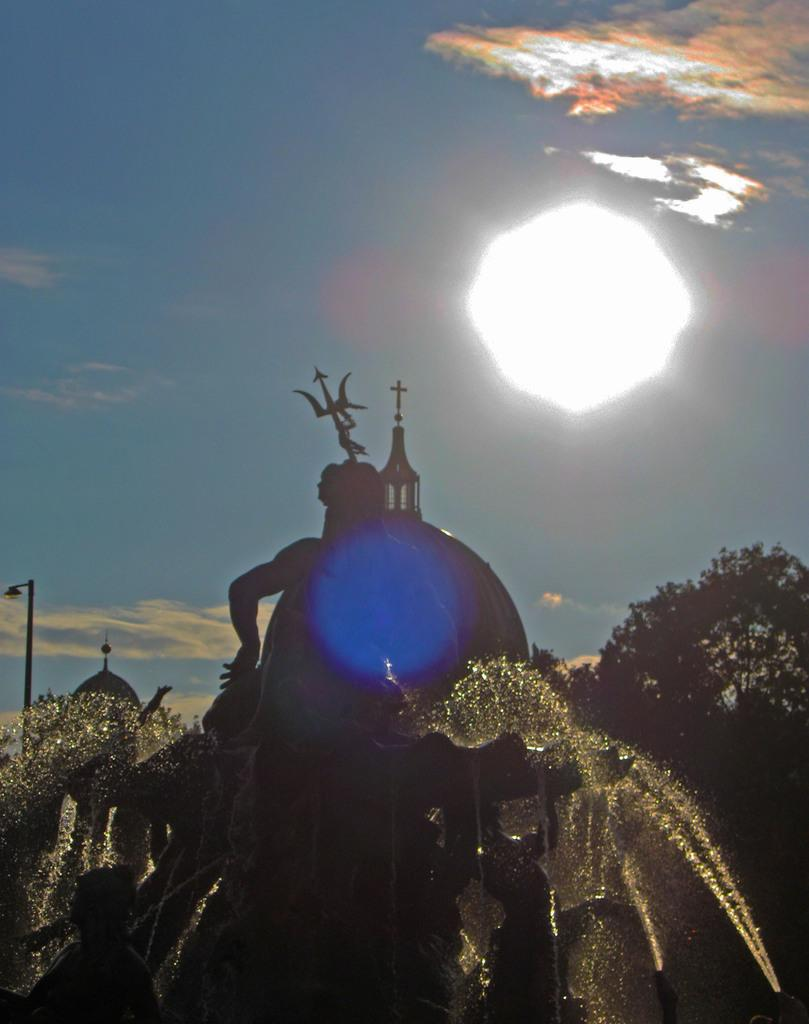What is located at the bottom of the image? There is a statue at the bottom of the image. What can be seen in the background of the image? There are trees, plants, and a pole in the background of the image. What is visible in the sky in the image? There are clouds and light in the sky. What type of ticket is the statue holding in the image? There is no ticket present in the image; the statue is not holding anything. 